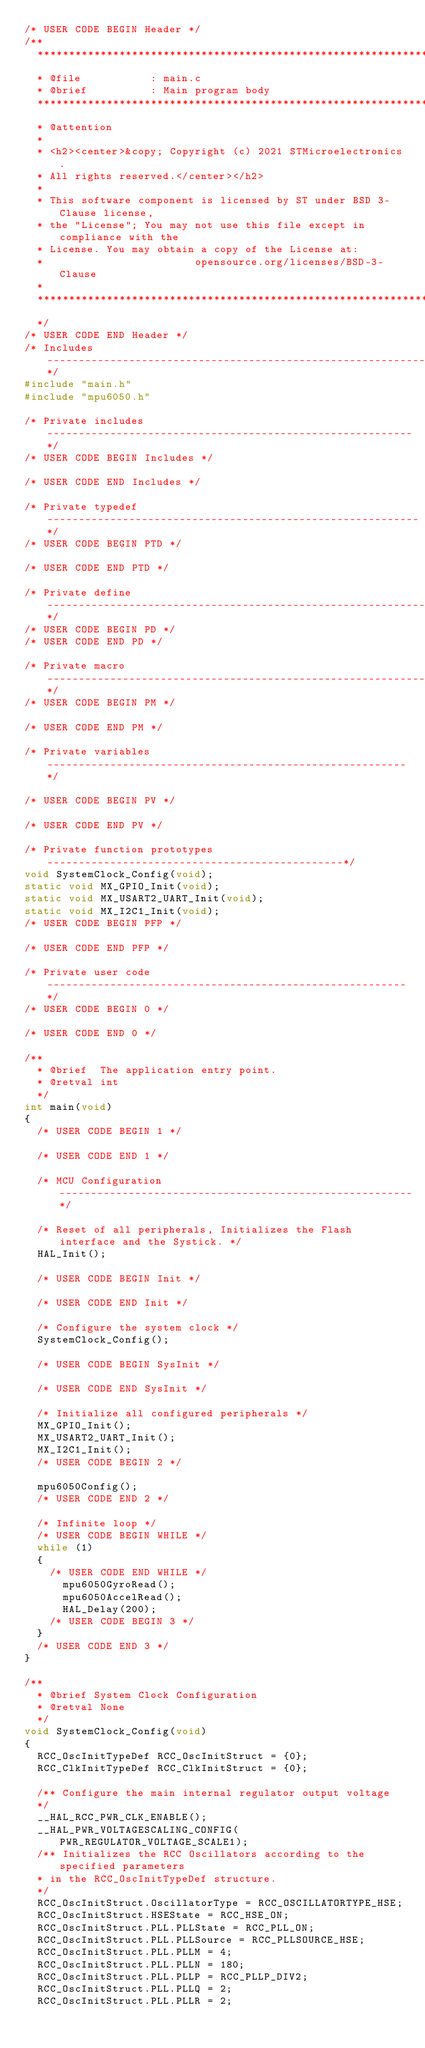<code> <loc_0><loc_0><loc_500><loc_500><_C_>/* USER CODE BEGIN Header */
/**
  ******************************************************************************
  * @file           : main.c
  * @brief          : Main program body
  ******************************************************************************
  * @attention
  *
  * <h2><center>&copy; Copyright (c) 2021 STMicroelectronics.
  * All rights reserved.</center></h2>
  *
  * This software component is licensed by ST under BSD 3-Clause license,
  * the "License"; You may not use this file except in compliance with the
  * License. You may obtain a copy of the License at:
  *                        opensource.org/licenses/BSD-3-Clause
  *
  ******************************************************************************
  */
/* USER CODE END Header */
/* Includes ------------------------------------------------------------------*/
#include "main.h"
#include "mpu6050.h"

/* Private includes ----------------------------------------------------------*/
/* USER CODE BEGIN Includes */

/* USER CODE END Includes */

/* Private typedef -----------------------------------------------------------*/
/* USER CODE BEGIN PTD */

/* USER CODE END PTD */

/* Private define ------------------------------------------------------------*/
/* USER CODE BEGIN PD */
/* USER CODE END PD */

/* Private macro -------------------------------------------------------------*/
/* USER CODE BEGIN PM */

/* USER CODE END PM */

/* Private variables ---------------------------------------------------------*/

/* USER CODE BEGIN PV */

/* USER CODE END PV */

/* Private function prototypes -----------------------------------------------*/
void SystemClock_Config(void);
static void MX_GPIO_Init(void);
static void MX_USART2_UART_Init(void);
static void MX_I2C1_Init(void);
/* USER CODE BEGIN PFP */

/* USER CODE END PFP */

/* Private user code ---------------------------------------------------------*/
/* USER CODE BEGIN 0 */

/* USER CODE END 0 */

/**
  * @brief  The application entry point.
  * @retval int
  */
int main(void)
{
  /* USER CODE BEGIN 1 */

  /* USER CODE END 1 */

  /* MCU Configuration--------------------------------------------------------*/

  /* Reset of all peripherals, Initializes the Flash interface and the Systick. */
  HAL_Init();

  /* USER CODE BEGIN Init */

  /* USER CODE END Init */

  /* Configure the system clock */
  SystemClock_Config();

  /* USER CODE BEGIN SysInit */

  /* USER CODE END SysInit */

  /* Initialize all configured peripherals */
  MX_GPIO_Init();
  MX_USART2_UART_Init();
  MX_I2C1_Init();
  /* USER CODE BEGIN 2 */

  mpu6050Config();
  /* USER CODE END 2 */

  /* Infinite loop */
  /* USER CODE BEGIN WHILE */
  while (1)
  {
    /* USER CODE END WHILE */
	  mpu6050GyroRead();
	  mpu6050AccelRead();
	  HAL_Delay(200);
    /* USER CODE BEGIN 3 */
  }
  /* USER CODE END 3 */
}

/**
  * @brief System Clock Configuration
  * @retval None
  */
void SystemClock_Config(void)
{
  RCC_OscInitTypeDef RCC_OscInitStruct = {0};
  RCC_ClkInitTypeDef RCC_ClkInitStruct = {0};

  /** Configure the main internal regulator output voltage
  */
  __HAL_RCC_PWR_CLK_ENABLE();
  __HAL_PWR_VOLTAGESCALING_CONFIG(PWR_REGULATOR_VOLTAGE_SCALE1);
  /** Initializes the RCC Oscillators according to the specified parameters
  * in the RCC_OscInitTypeDef structure.
  */
  RCC_OscInitStruct.OscillatorType = RCC_OSCILLATORTYPE_HSE;
  RCC_OscInitStruct.HSEState = RCC_HSE_ON;
  RCC_OscInitStruct.PLL.PLLState = RCC_PLL_ON;
  RCC_OscInitStruct.PLL.PLLSource = RCC_PLLSOURCE_HSE;
  RCC_OscInitStruct.PLL.PLLM = 4;
  RCC_OscInitStruct.PLL.PLLN = 180;
  RCC_OscInitStruct.PLL.PLLP = RCC_PLLP_DIV2;
  RCC_OscInitStruct.PLL.PLLQ = 2;
  RCC_OscInitStruct.PLL.PLLR = 2;</code> 